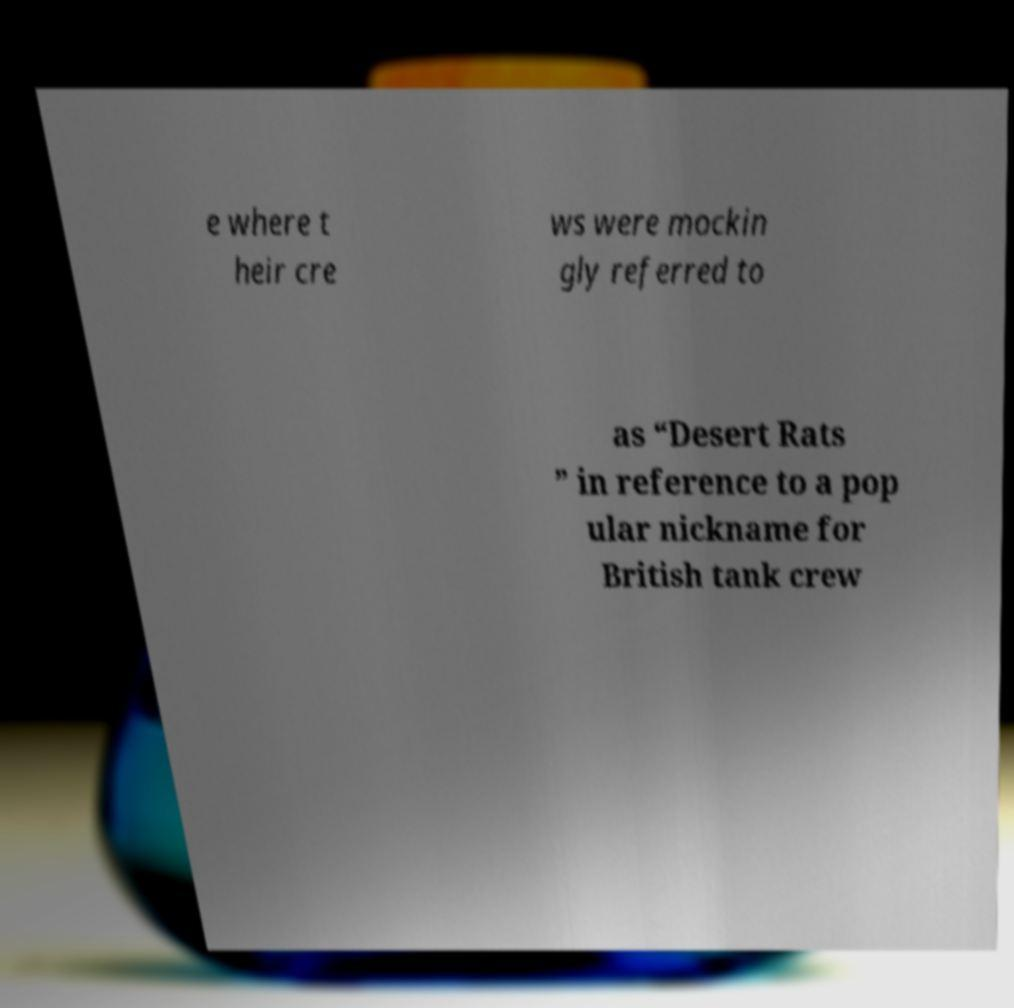Can you accurately transcribe the text from the provided image for me? e where t heir cre ws were mockin gly referred to as “Desert Rats ” in reference to a pop ular nickname for British tank crew 